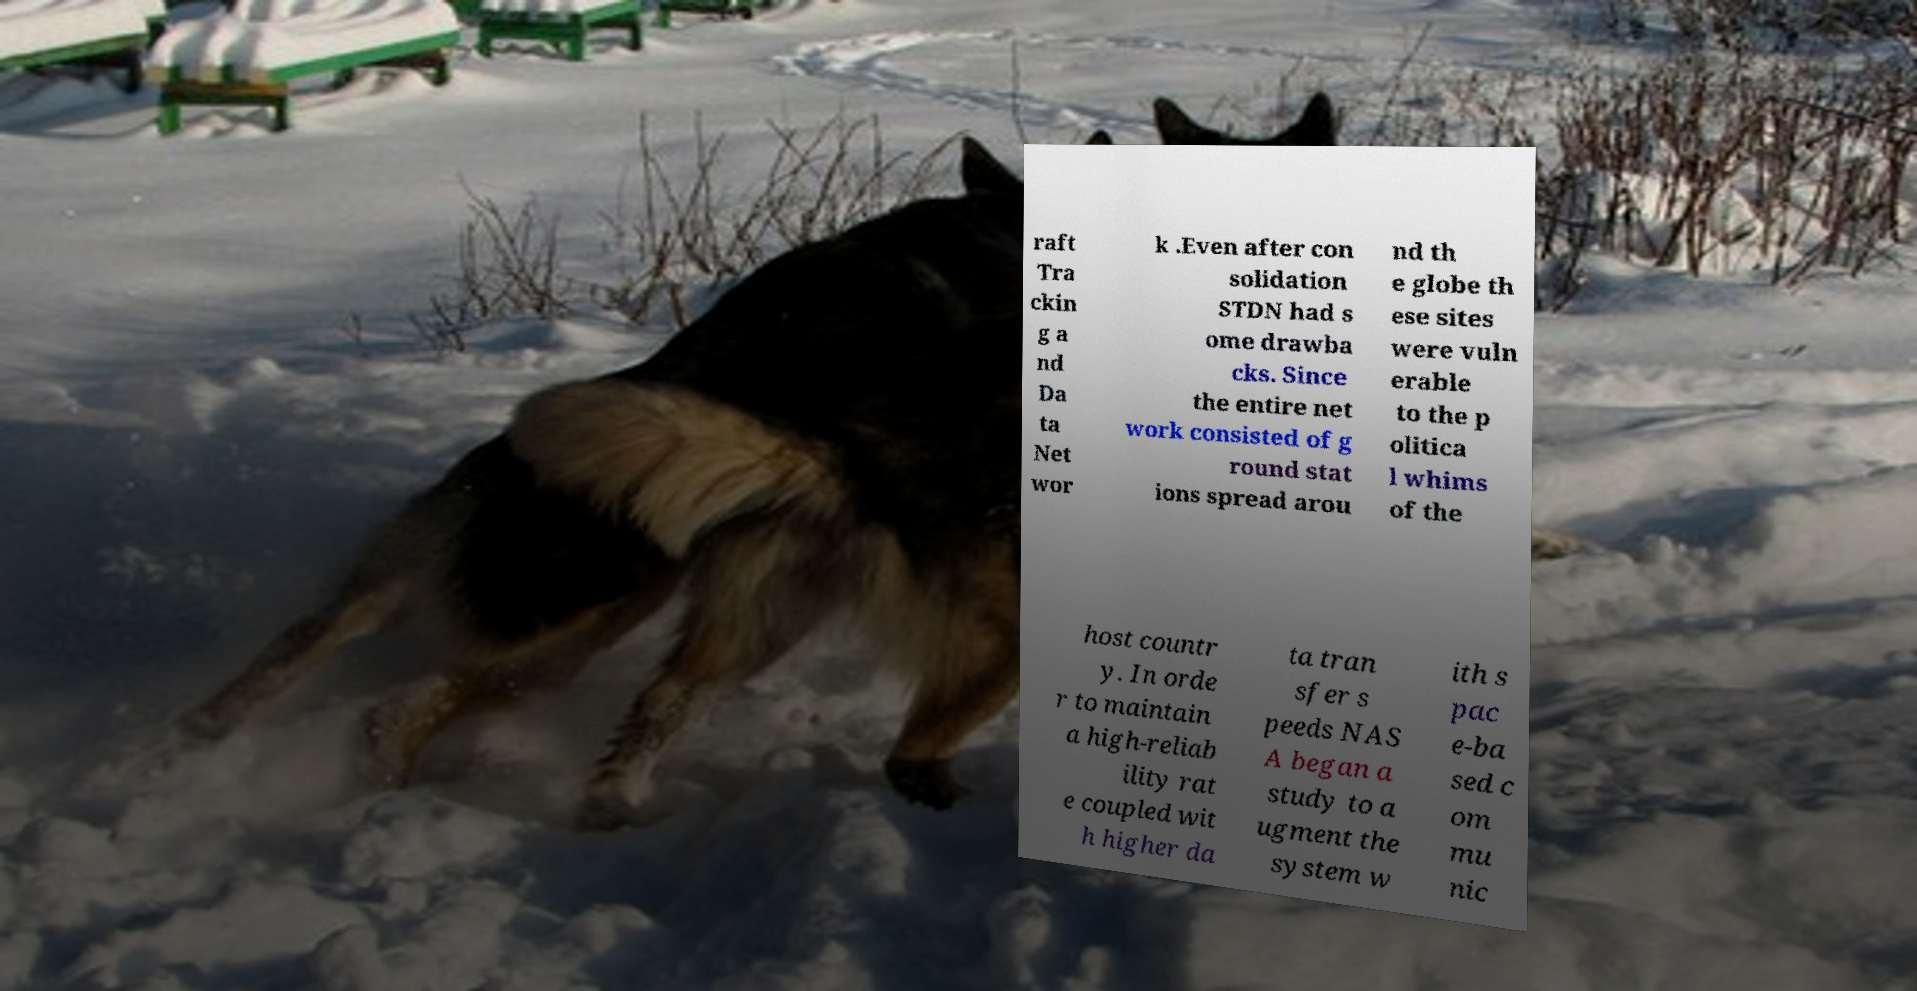Could you extract and type out the text from this image? raft Tra ckin g a nd Da ta Net wor k .Even after con solidation STDN had s ome drawba cks. Since the entire net work consisted of g round stat ions spread arou nd th e globe th ese sites were vuln erable to the p olitica l whims of the host countr y. In orde r to maintain a high-reliab ility rat e coupled wit h higher da ta tran sfer s peeds NAS A began a study to a ugment the system w ith s pac e-ba sed c om mu nic 